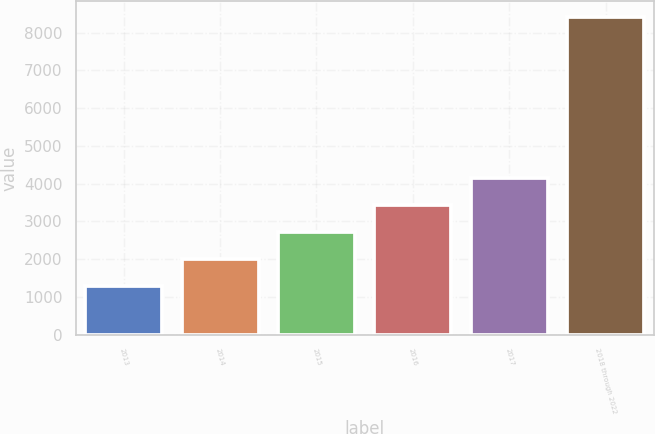Convert chart to OTSL. <chart><loc_0><loc_0><loc_500><loc_500><bar_chart><fcel>2013<fcel>2014<fcel>2015<fcel>2016<fcel>2017<fcel>2018 through 2022<nl><fcel>1291<fcel>2002.9<fcel>2714.8<fcel>3426.7<fcel>4138.6<fcel>8410<nl></chart> 